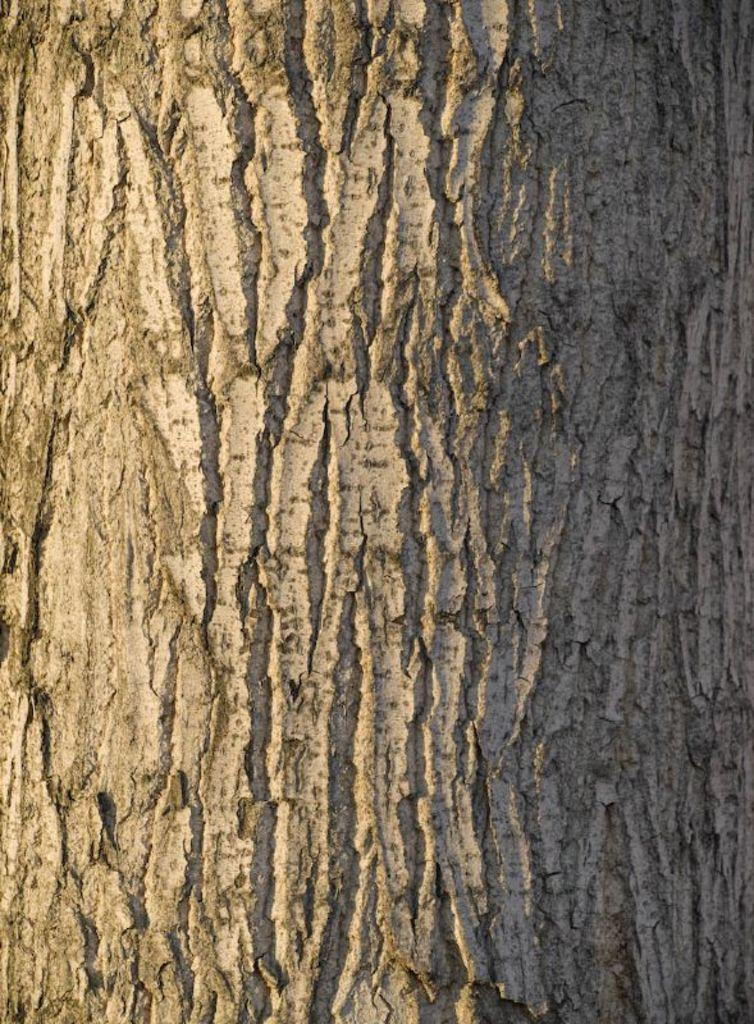What is the main subject of the image? The main subject of the image is a tree trunk. Can you describe the tree trunk in the image? The tree trunk appears to be a large, solid piece of wood. Are there any other objects or features visible in the image? The provided facts do not mention any other objects or features in the image. How many boys are jumping over the tree trunk in the image? There are no boys or jumping visible in the image; it only features a tree trunk. 